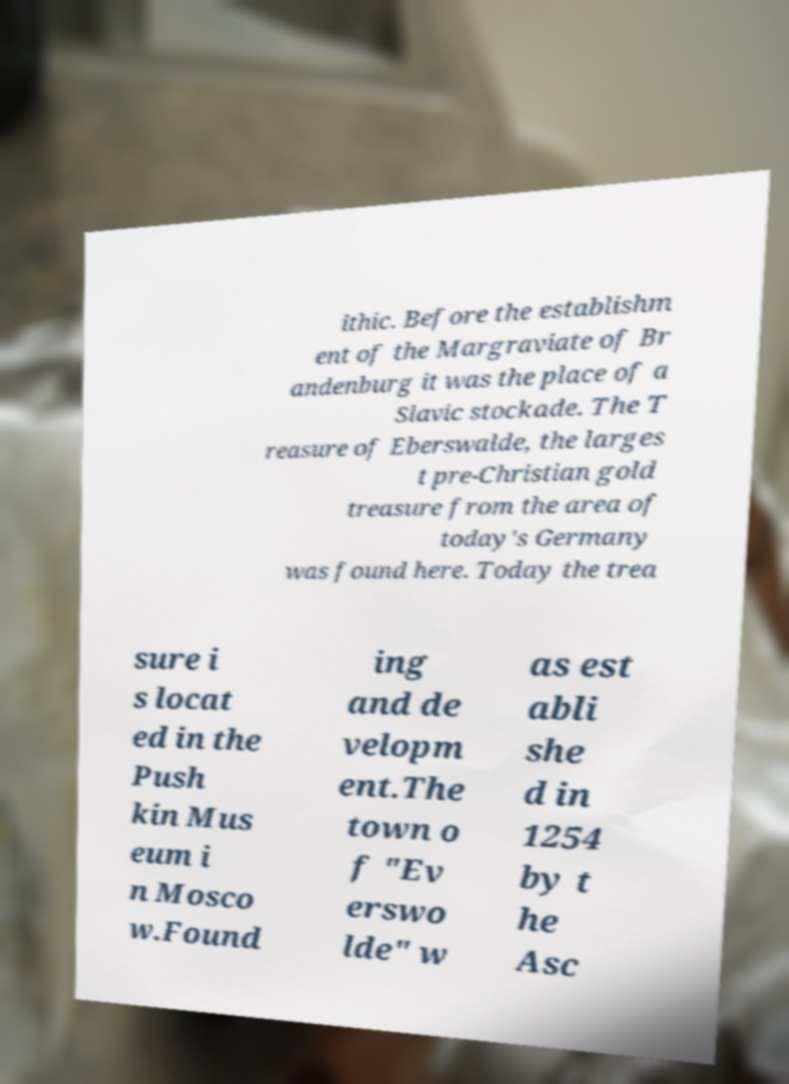What messages or text are displayed in this image? I need them in a readable, typed format. ithic. Before the establishm ent of the Margraviate of Br andenburg it was the place of a Slavic stockade. The T reasure of Eberswalde, the larges t pre-Christian gold treasure from the area of today's Germany was found here. Today the trea sure i s locat ed in the Push kin Mus eum i n Mosco w.Found ing and de velopm ent.The town o f "Ev erswo lde" w as est abli she d in 1254 by t he Asc 